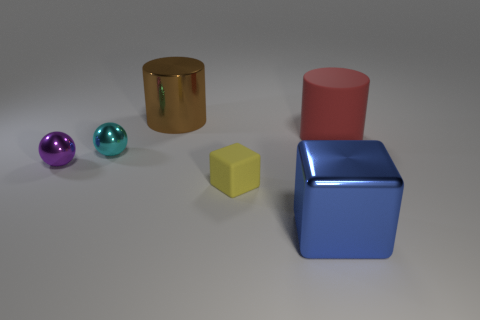Is the sphere that is behind the small purple metallic sphere made of the same material as the tiny purple object?
Keep it short and to the point. Yes. What color is the metal thing that is behind the rubber cylinder?
Your answer should be compact. Brown. Are there any blue rubber cylinders that have the same size as the red rubber cylinder?
Offer a very short reply. No. What material is the cyan object that is the same size as the yellow object?
Offer a very short reply. Metal. Do the purple shiny object and the red thing right of the tiny matte block have the same size?
Your answer should be compact. No. There is a big cylinder that is right of the metallic block; what is its material?
Your answer should be compact. Rubber. Are there the same number of red things on the left side of the brown cylinder and purple matte spheres?
Provide a short and direct response. Yes. Is the brown cylinder the same size as the yellow rubber object?
Provide a short and direct response. No. There is a large thing in front of the matte thing on the left side of the large red rubber cylinder; are there any balls behind it?
Your answer should be compact. Yes. There is another large thing that is the same shape as the yellow matte object; what is its material?
Keep it short and to the point. Metal. 